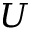Convert formula to latex. <formula><loc_0><loc_0><loc_500><loc_500>U</formula> 